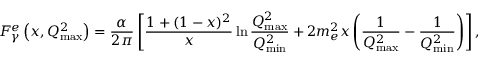<formula> <loc_0><loc_0><loc_500><loc_500>F _ { \gamma } ^ { e } \left ( x , Q _ { \max } ^ { 2 } \right ) = { \frac { \alpha } { 2 \pi } } \left [ { \frac { 1 + ( 1 - x ) ^ { 2 } } { x } } \ln { \frac { Q _ { \max } ^ { 2 } } { Q _ { \min } ^ { 2 } } } + 2 m _ { e } ^ { 2 } x \left ( { \frac { 1 } { Q _ { \max } ^ { 2 } } } - { \frac { 1 } { Q _ { \min } ^ { 2 } } } \right ) \right ] ,</formula> 